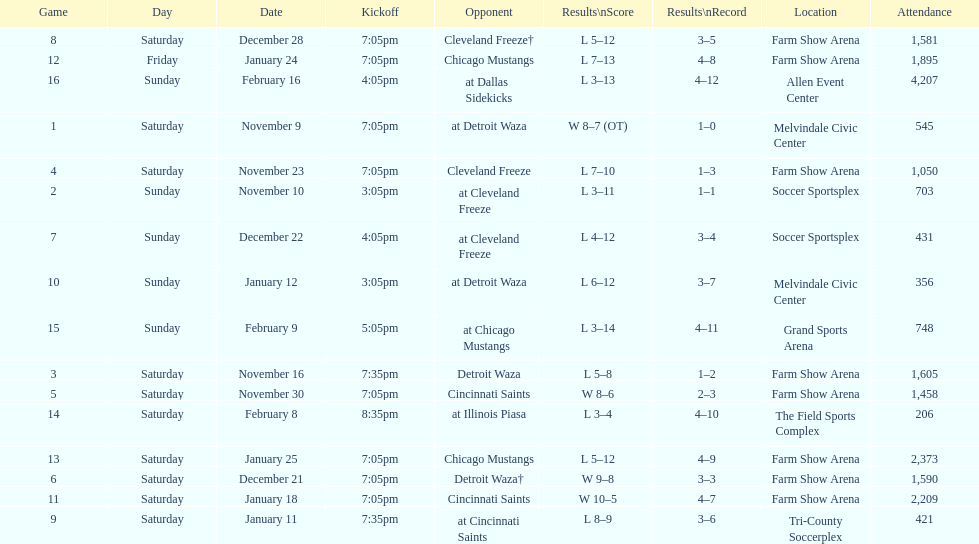What was the longest period of consecutive losses for the team? 5 games. 